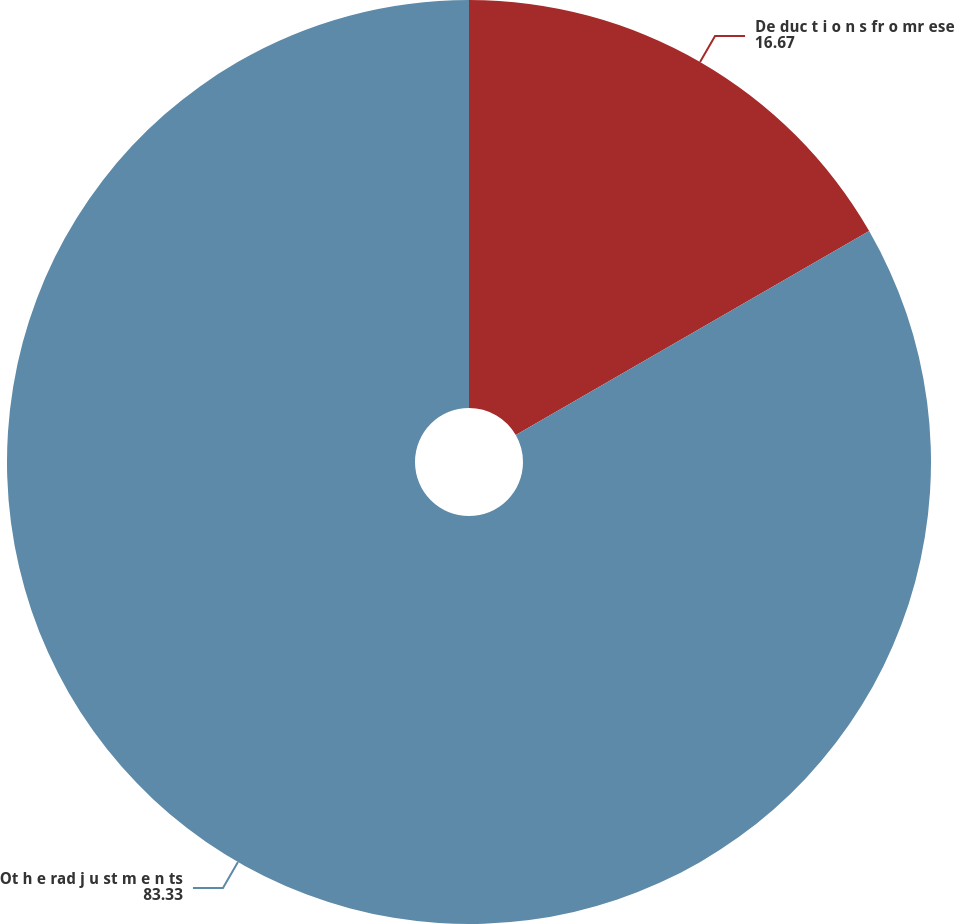Convert chart to OTSL. <chart><loc_0><loc_0><loc_500><loc_500><pie_chart><fcel>De duc t i o n s fr o mr ese<fcel>Ot h e rad j u st m e n ts<nl><fcel>16.67%<fcel>83.33%<nl></chart> 